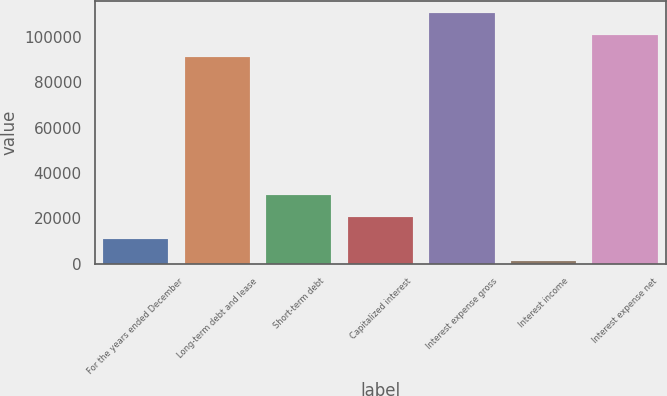Convert chart. <chart><loc_0><loc_0><loc_500><loc_500><bar_chart><fcel>For the years ended December<fcel>Long-term debt and lease<fcel>Short-term debt<fcel>Capitalized interest<fcel>Interest expense gross<fcel>Interest income<fcel>Interest expense net<nl><fcel>10913.4<fcel>91144<fcel>30200.2<fcel>20556.8<fcel>110431<fcel>1270<fcel>100787<nl></chart> 